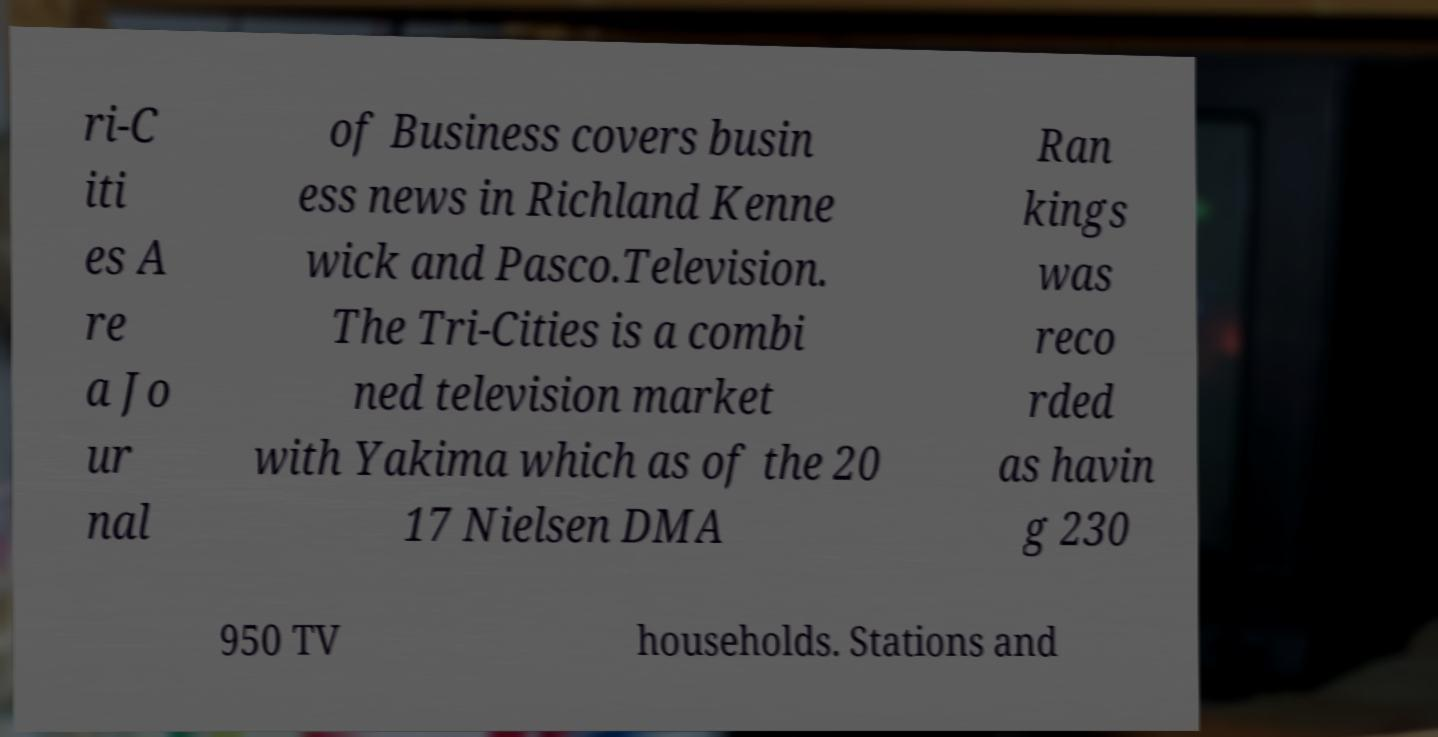Can you read and provide the text displayed in the image?This photo seems to have some interesting text. Can you extract and type it out for me? ri-C iti es A re a Jo ur nal of Business covers busin ess news in Richland Kenne wick and Pasco.Television. The Tri-Cities is a combi ned television market with Yakima which as of the 20 17 Nielsen DMA Ran kings was reco rded as havin g 230 950 TV households. Stations and 